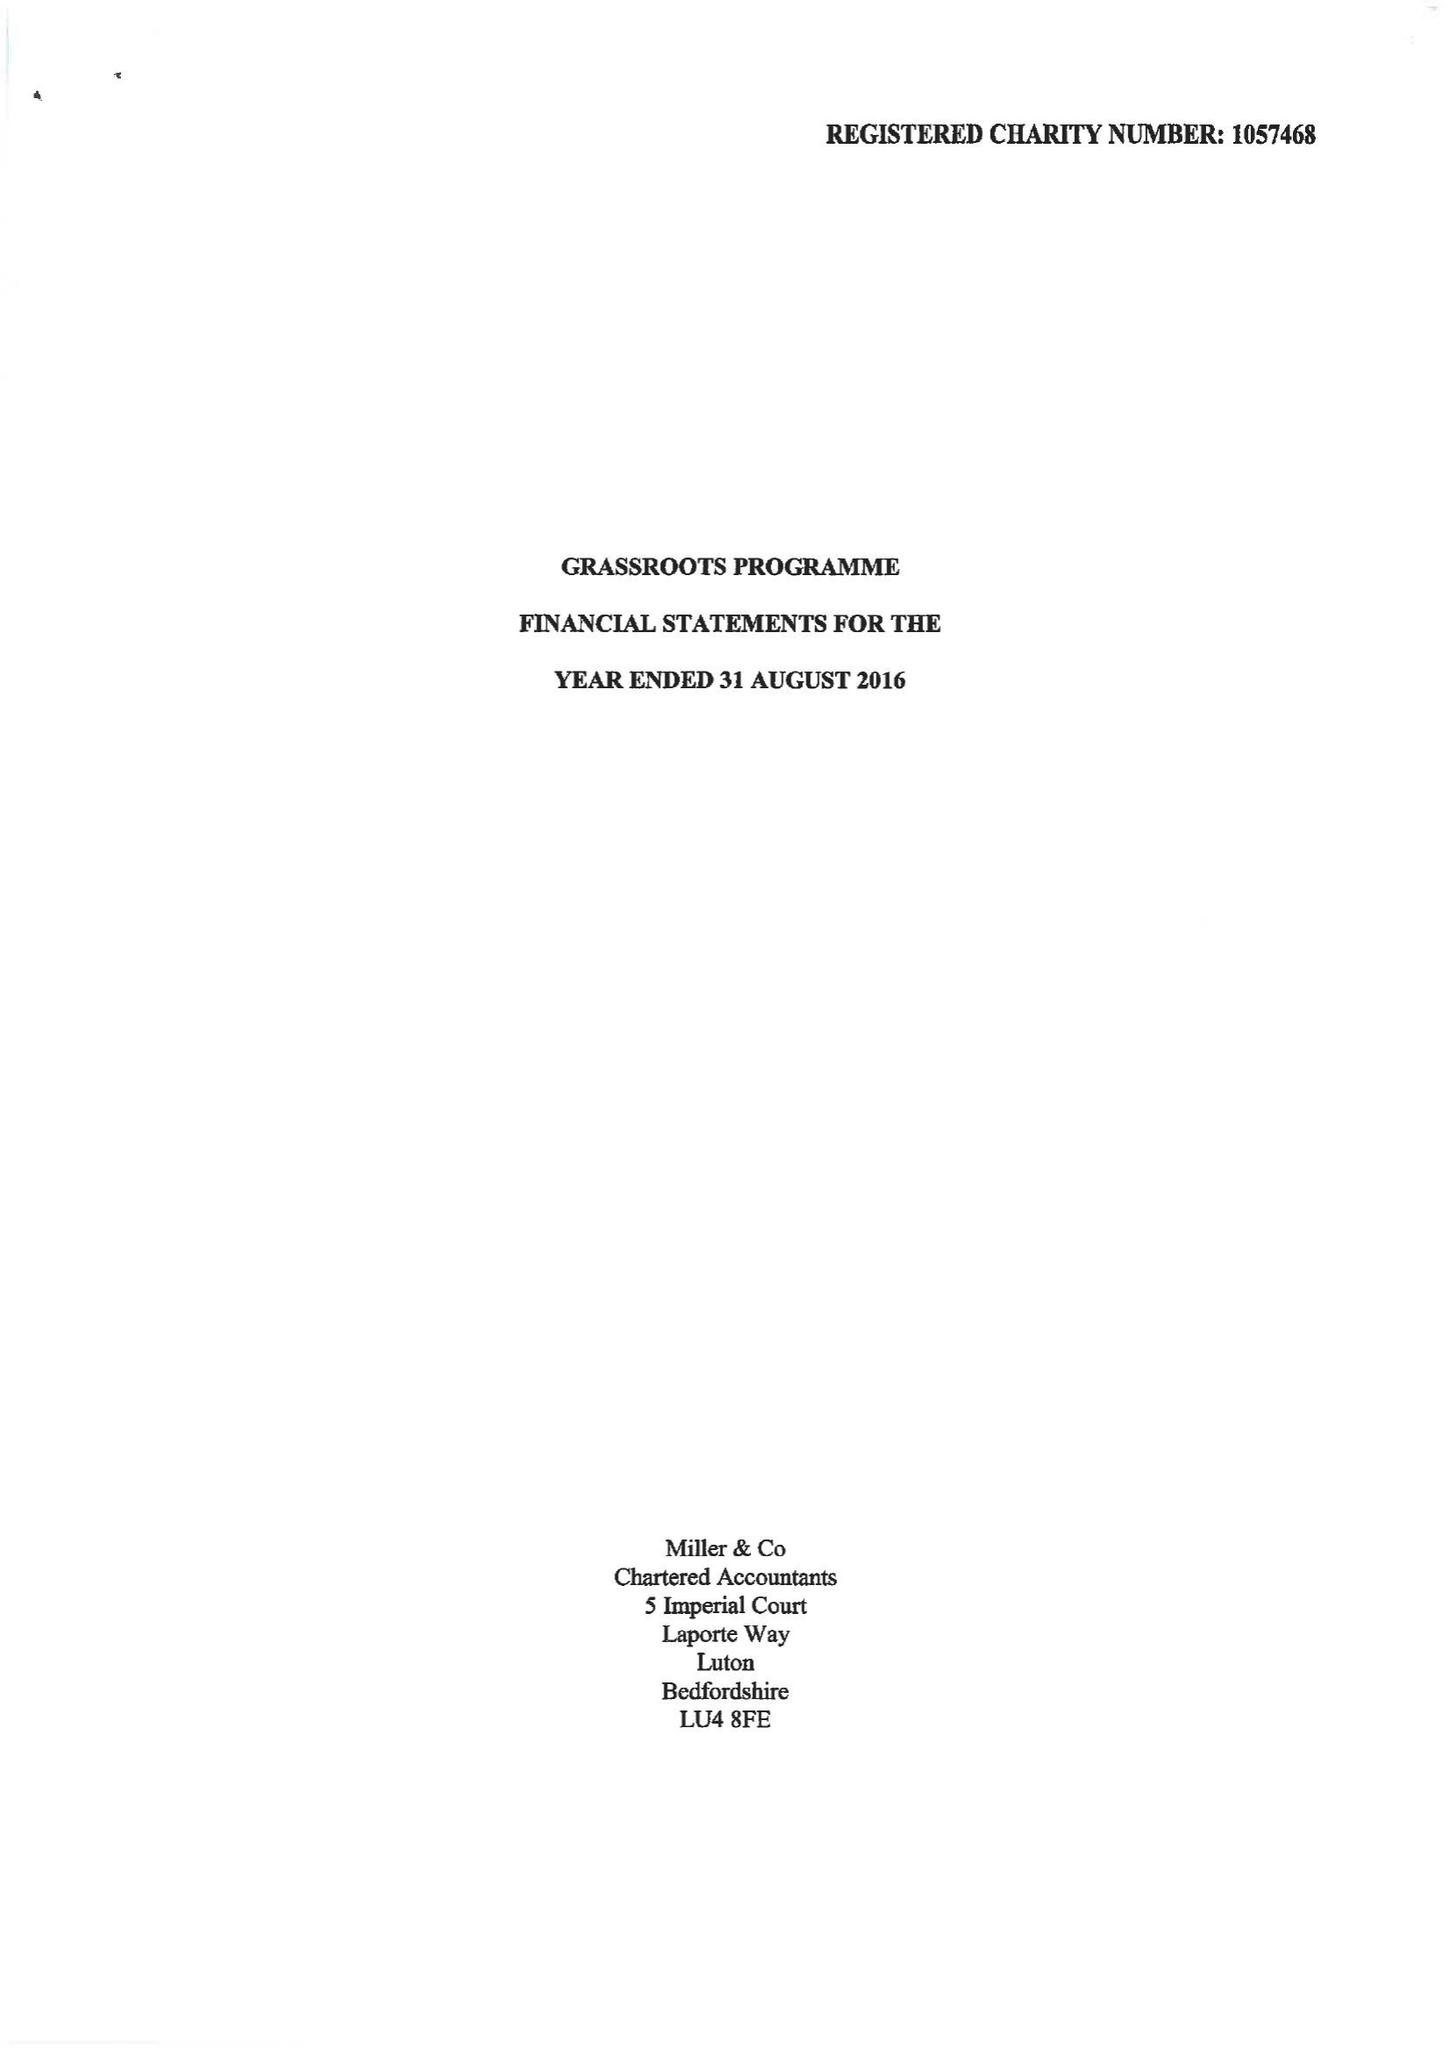What is the value for the address__postcode?
Answer the question using a single word or phrase. LU2 0BW 